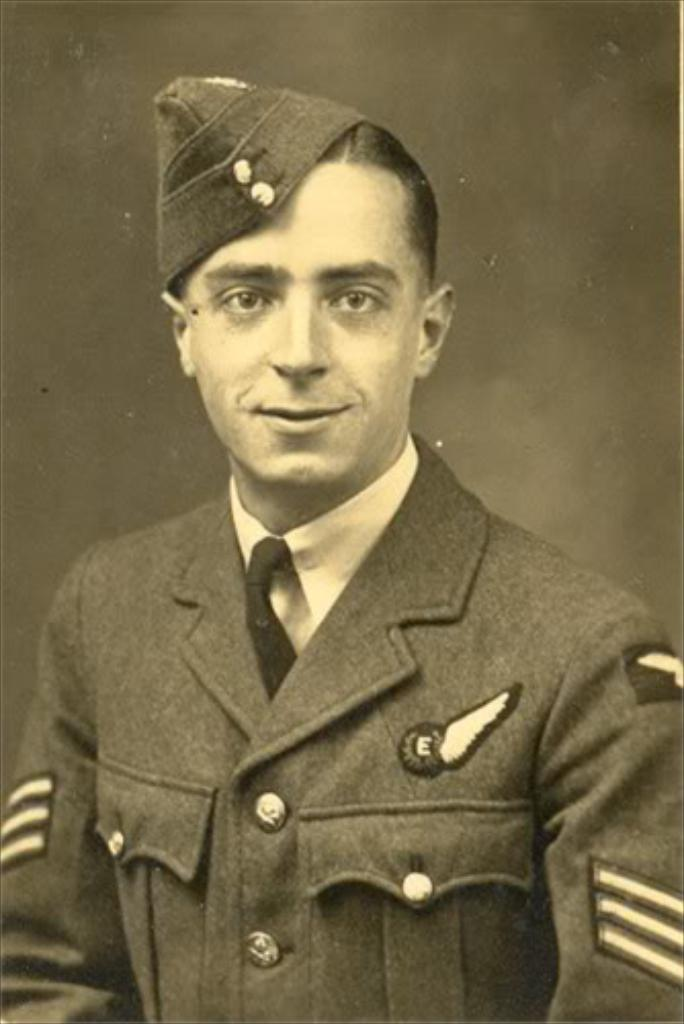What is the main subject of the photo? There is a person in the photo. What is the person wearing on their head? The person is wearing a cap. What is the person's facial expression in the photo? The person is smiling. What type of earth can be seen in the photo? There is no earth visible in the photo; it features a person wearing a cap and smiling. What kind of quartz is present in the photo? There is no quartz present in the photo; it features a person wearing a cap and smiling. 